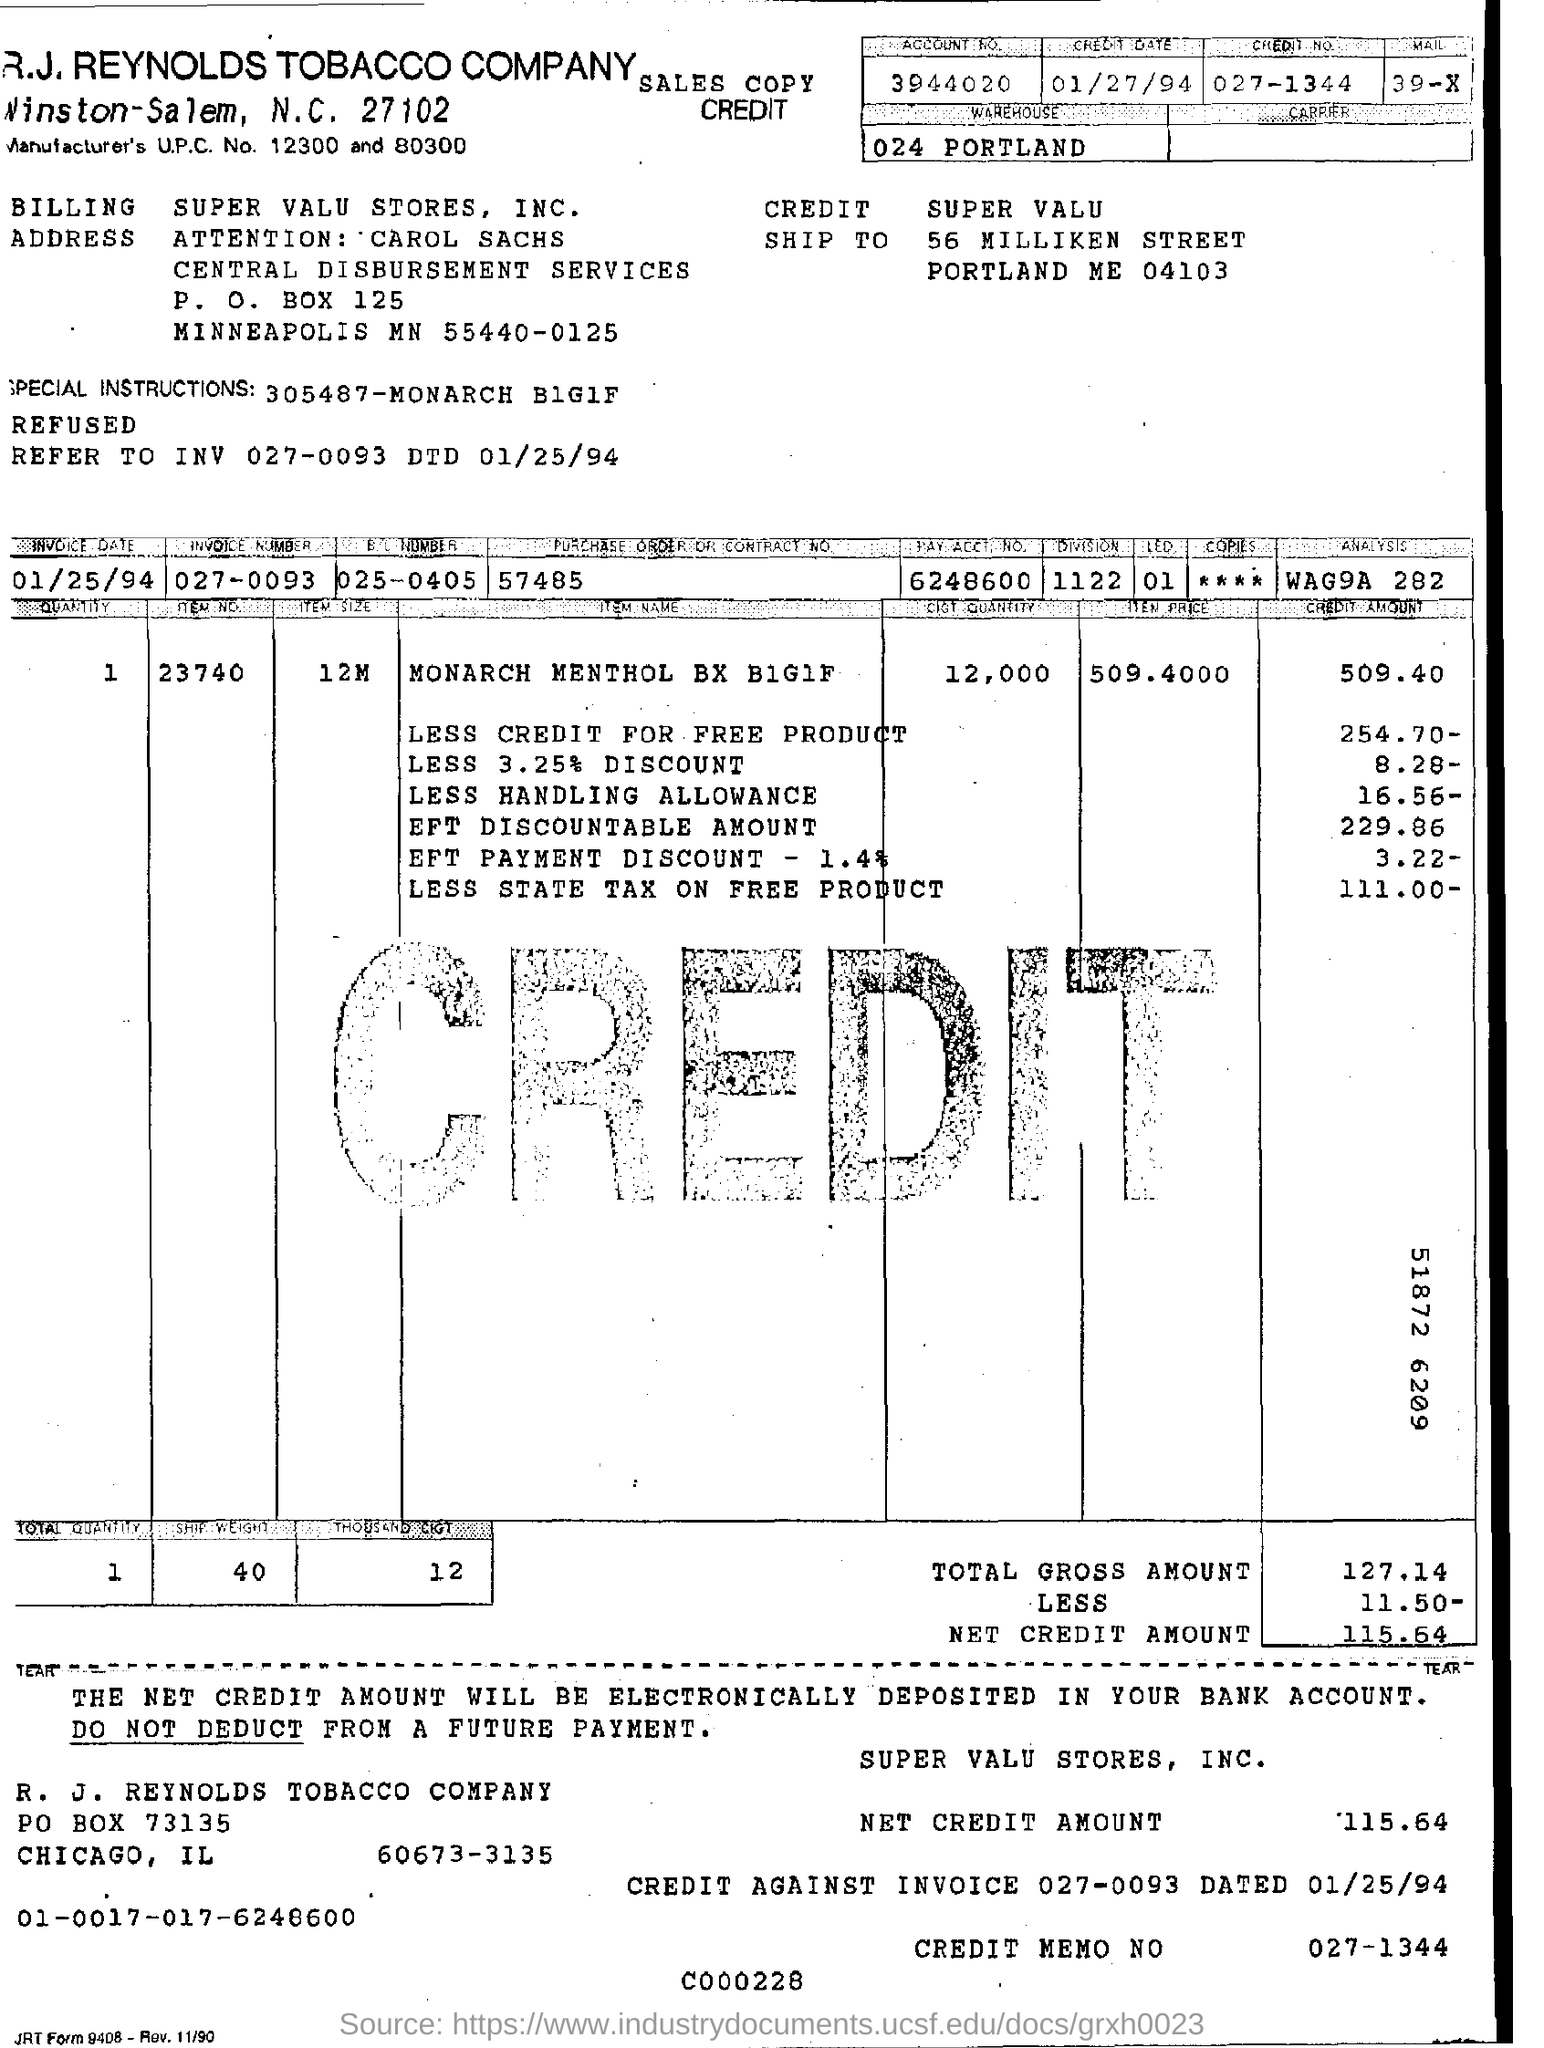Draw attention to some important aspects in this diagram. What is the date of the invoice? The invoice was issued on January 25, 1994. The less handling allowance is 16.56, and credit amount is required. R.J. Reynolds Tobacco Company sent a billing to Supervalu Stores, Inc. for a purchase made by them. 